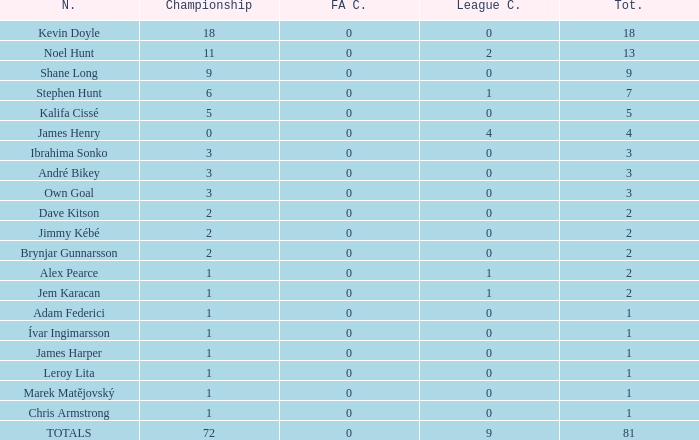What is the total championships of James Henry that has a league cup more than 1? 0.0. 